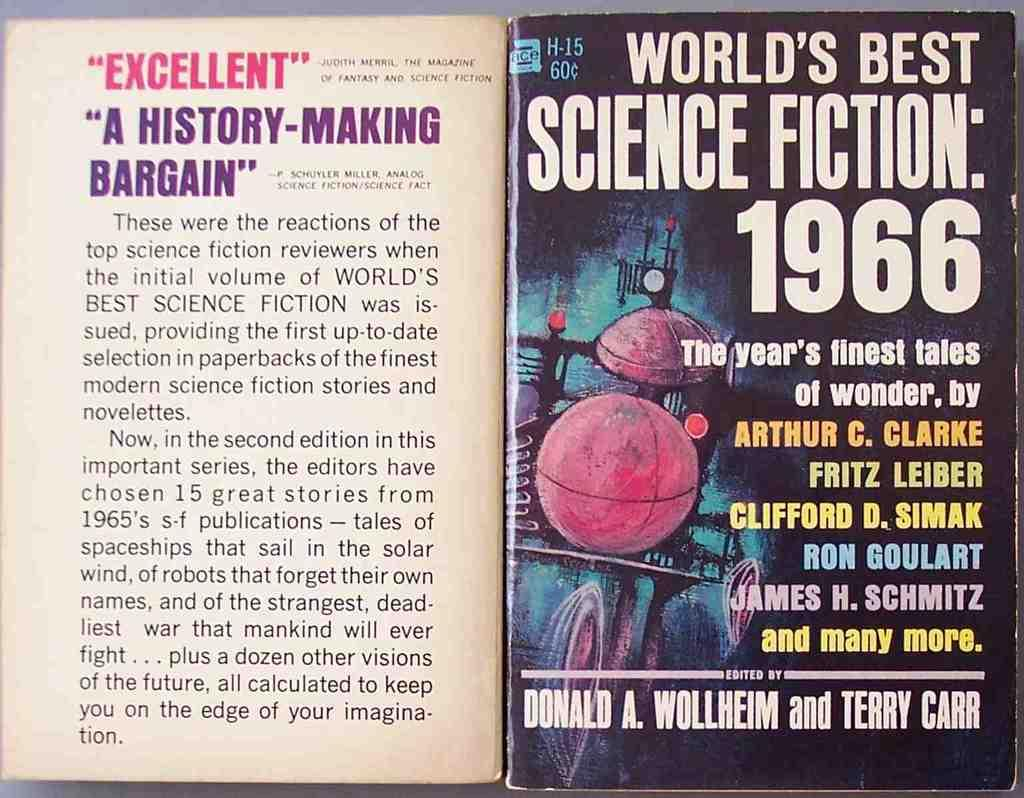Provide a one-sentence caption for the provided image. Book cover that says "World's Best Science Fiction" from the year 1966. 